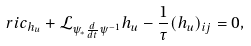Convert formula to latex. <formula><loc_0><loc_0><loc_500><loc_500>\ r i c _ { h _ { u } } + \mathcal { L } _ { \psi _ { * } \frac { d } { d t } \psi ^ { - 1 } } h _ { u } - \frac { 1 } { \tau } ( h _ { u } ) _ { i j } = 0 ,</formula> 